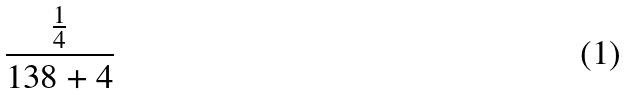<formula> <loc_0><loc_0><loc_500><loc_500>\frac { \frac { 1 } { 4 } } { 1 3 8 + 4 }</formula> 